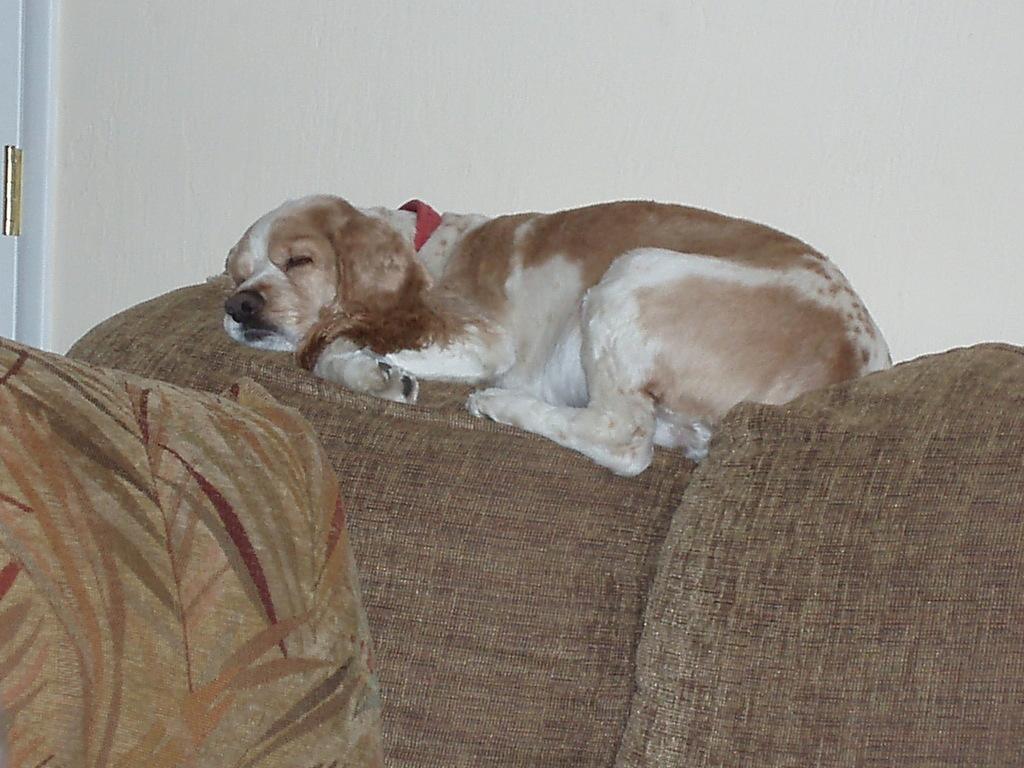How would you summarize this image in a sentence or two? In this image I can see a dog is sleeping on the sofa, it is in white and brown color. On the left side there is the pillow. 